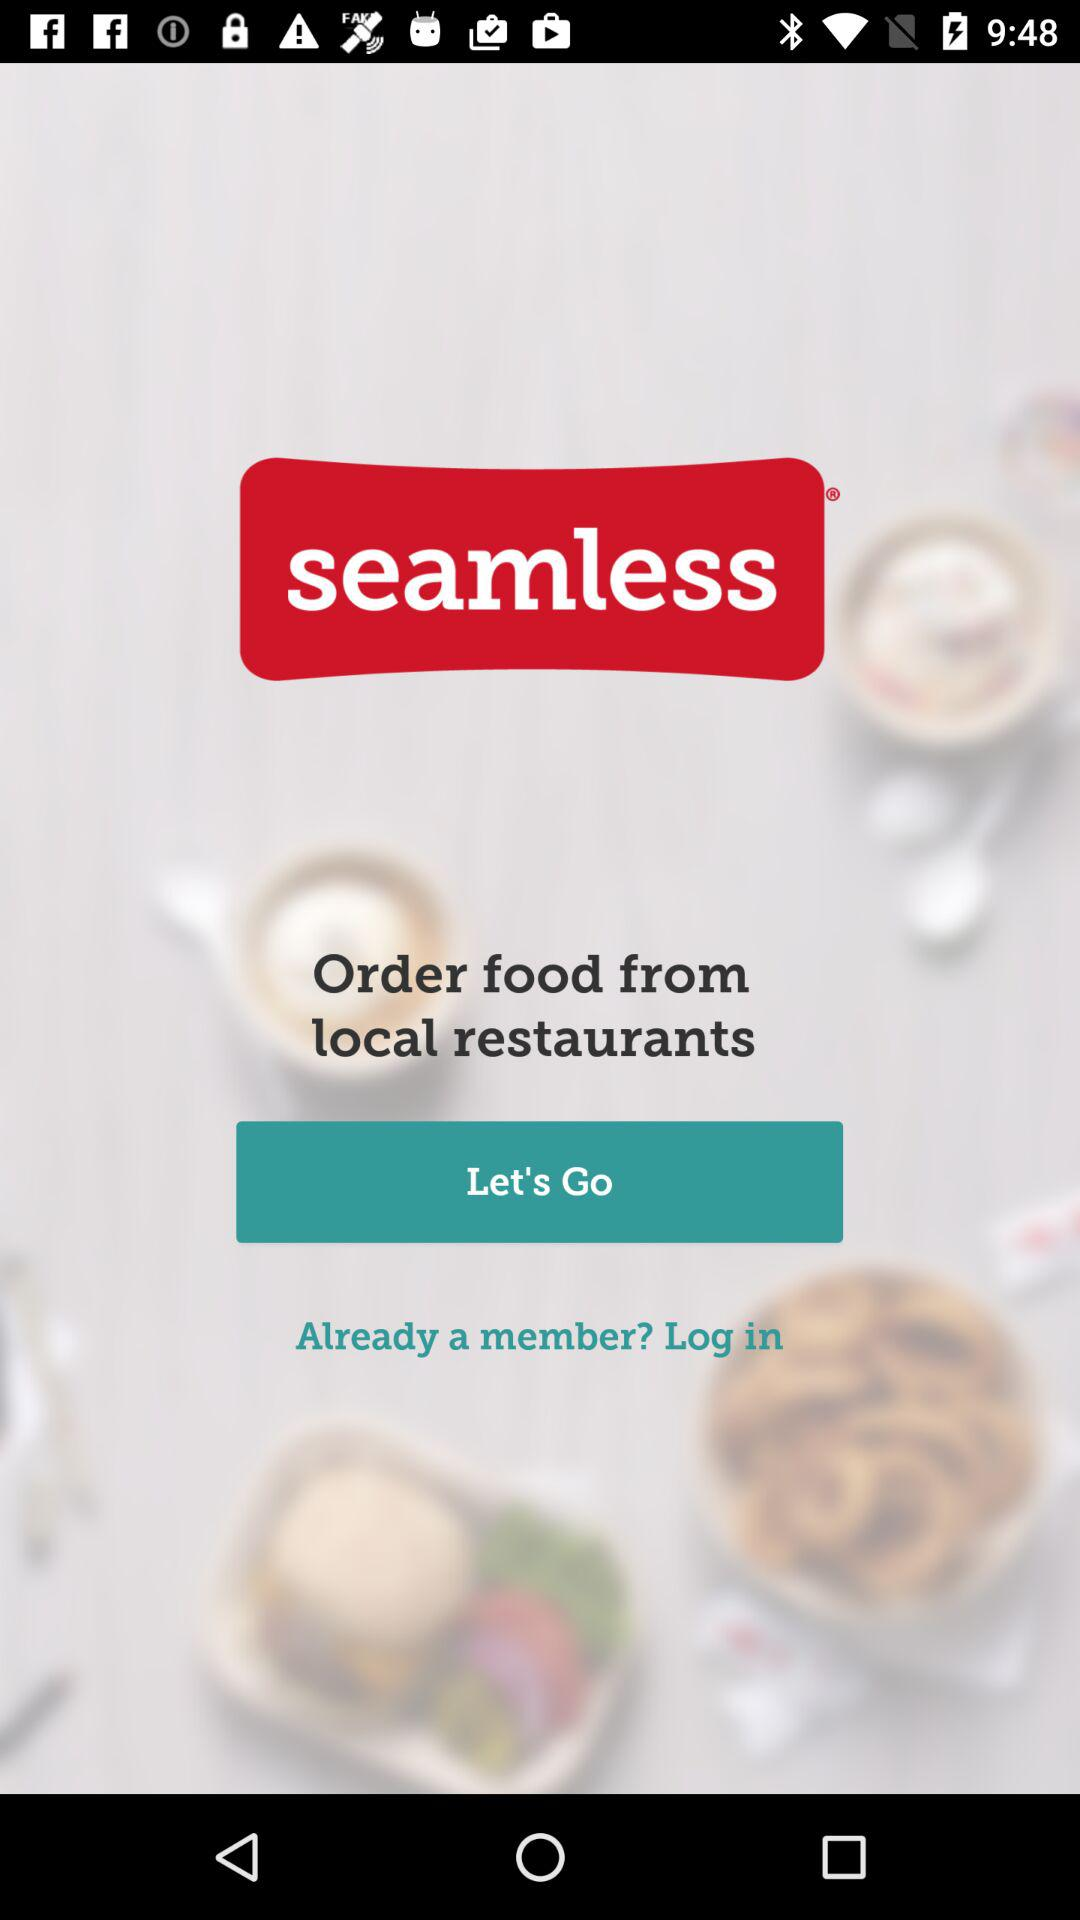From where can we order the food? You can order the food from local restaurants. 